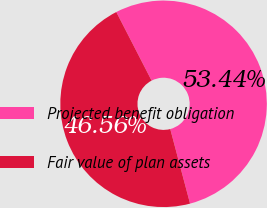<chart> <loc_0><loc_0><loc_500><loc_500><pie_chart><fcel>Projected benefit obligation<fcel>Fair value of plan assets<nl><fcel>53.44%<fcel>46.56%<nl></chart> 